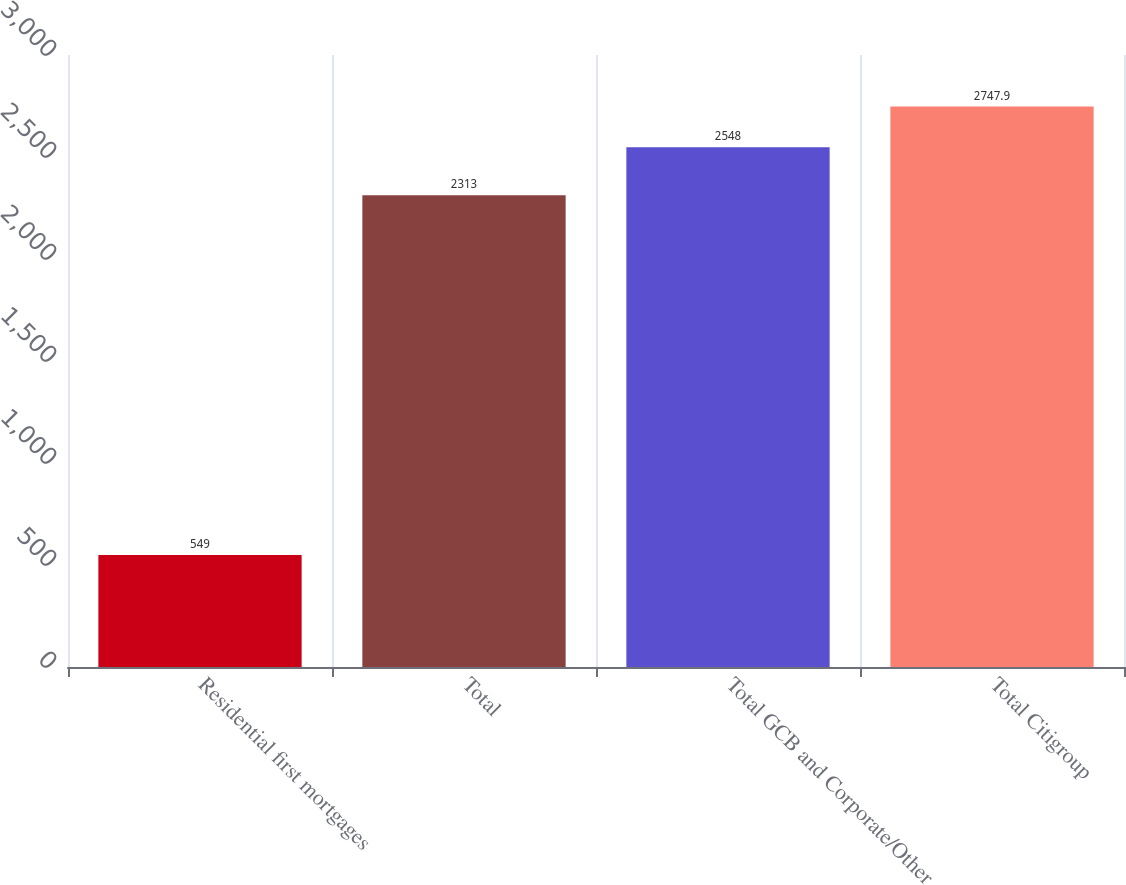Convert chart to OTSL. <chart><loc_0><loc_0><loc_500><loc_500><bar_chart><fcel>Residential first mortgages<fcel>Total<fcel>Total GCB and Corporate/Other<fcel>Total Citigroup<nl><fcel>549<fcel>2313<fcel>2548<fcel>2747.9<nl></chart> 